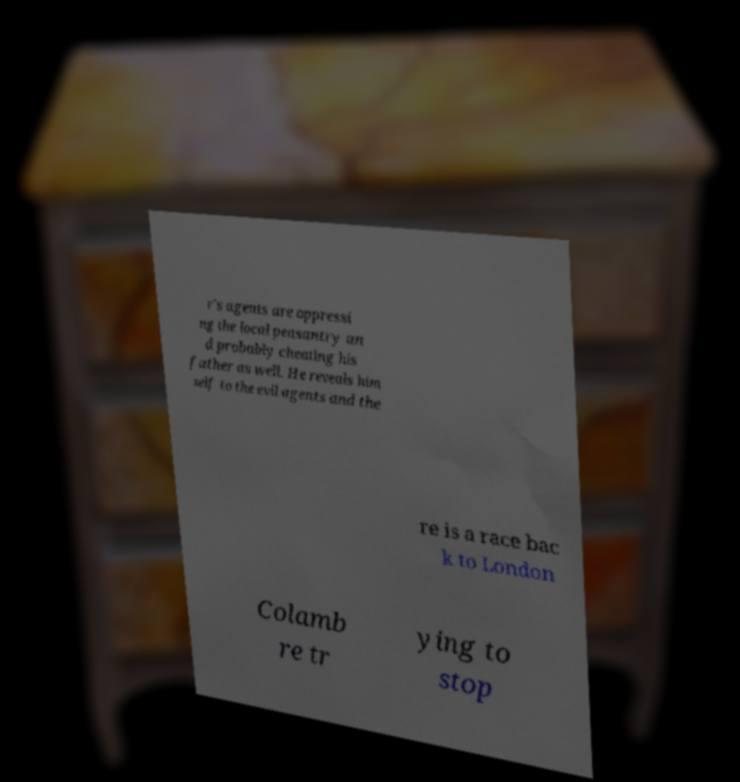I need the written content from this picture converted into text. Can you do that? r's agents are oppressi ng the local peasantry an d probably cheating his father as well. He reveals him self to the evil agents and the re is a race bac k to London Colamb re tr ying to stop 